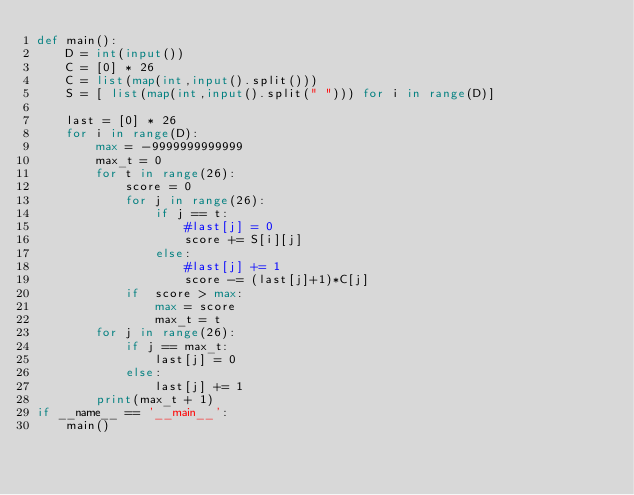Convert code to text. <code><loc_0><loc_0><loc_500><loc_500><_Python_>def main():
    D = int(input())
    C = [0] * 26
    C = list(map(int,input().split()))
    S = [ list(map(int,input().split(" "))) for i in range(D)]
    
    last = [0] * 26
    for i in range(D):
        max = -9999999999999
        max_t = 0
        for t in range(26):
            score = 0
            for j in range(26):
                if j == t:
                    #last[j] = 0
                    score += S[i][j]
                else:
                    #last[j] += 1
                    score -= (last[j]+1)*C[j]
            if  score > max:
                max = score
                max_t = t
        for j in range(26):
            if j == max_t:
                last[j] = 0
            else:
                last[j] += 1
        print(max_t + 1)
if __name__ == '__main__':
    main()</code> 